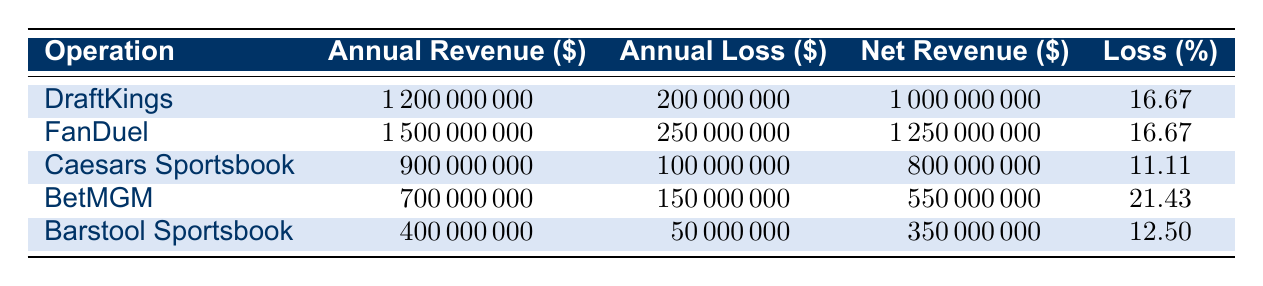What is the annual revenue of FanDuel? The annual revenue for FanDuel is listed directly in the table under the "Annual Revenue" column, which states that it is 1,500,000,000 dollars.
Answer: 1,500,000,000 What is the percentage loss for Caesars Sportsbook? The percentage loss for Caesars Sportsbook can be found in the "Loss (%)" column. According to the table, it is listed as 11.11%.
Answer: 11.11 Which sports betting operation had the highest net revenue in the fiscal year 2022? To find the highest net revenue, we look at the "Net Revenue" column for all operations and determine which value is greatest. FanDuel has the highest net revenue of 1,250,000,000 dollars.
Answer: FanDuel How much total annual revenue is generated by all the operations combined? We need to sum the annual revenues from each operation: DraftKings (1,200,000,000) + FanDuel (1,500,000,000) + Caesars Sportsbook (900,000,000) + BetMGM (700,000,000) + Barstool Sportsbook (400,000,000) = 4,700,000,000.
Answer: 4,700,000,000 Is the annual loss of BetMGM greater than 150 million dollars? The table shows that the annual loss for BetMGM is 150,000,000 dollars. Since it is not greater than this amount, the answer is no.
Answer: No What is the average annual loss among all listed sports betting operations? First, we sum the annual losses: 200,000,000 (DraftKings) + 250,000,000 (FanDuel) + 100,000,000 (Caesars Sportsbook) + 150,000,000 (BetMGM) + 50,000,000 (Barstool Sportsbook) = 750,000,000. There are 5 operations, so we divide 750,000,000 by 5, giving an average loss of 150,000,000 dollars.
Answer: 150,000,000 Does Barstool Sportsbook have a higher annual revenue than BetMGM? Comparing the "Annual Revenue" for both: Barstool Sportsbook has 400,000,000, and BetMGM has 700,000,000. Since 400,000,000 is not greater than 700,000,000, the answer is no.
Answer: No What is the net revenue difference between DraftKings and Caesars Sportsbook? The net revenue for DraftKings is 1,000,000,000 and for Caesars Sportsbook, it is 800,000,000. We calculate the difference: 1,000,000,000 - 800,000,000 = 200,000,000.
Answer: 200,000,000 